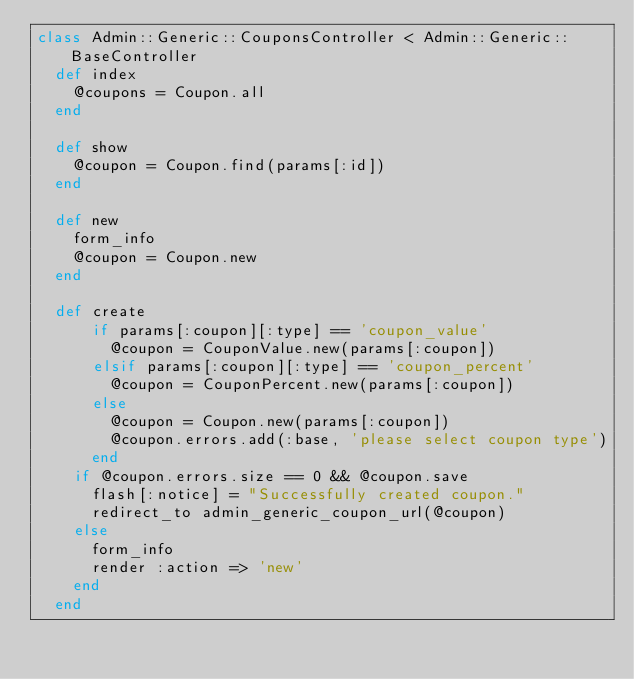Convert code to text. <code><loc_0><loc_0><loc_500><loc_500><_Ruby_>class Admin::Generic::CouponsController < Admin::Generic::BaseController
  def index
    @coupons = Coupon.all
  end

  def show
    @coupon = Coupon.find(params[:id])
  end

  def new
    form_info
    @coupon = Coupon.new
  end

  def create
      if params[:coupon][:type] == 'coupon_value'
        @coupon = CouponValue.new(params[:coupon])
      elsif params[:coupon][:type] == 'coupon_percent'
        @coupon = CouponPercent.new(params[:coupon])
      else
        @coupon = Coupon.new(params[:coupon])
        @coupon.errors.add(:base, 'please select coupon type')
      end
    if @coupon.errors.size == 0 && @coupon.save
      flash[:notice] = "Successfully created coupon."
      redirect_to admin_generic_coupon_url(@coupon)
    else
      form_info
      render :action => 'new'
    end
  end
</code> 